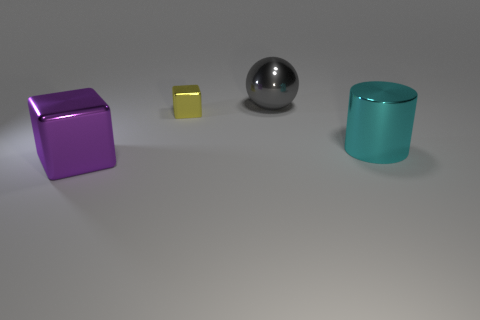Add 4 big cyan metal cylinders. How many objects exist? 8 Subtract all cylinders. How many objects are left? 3 Subtract all small metallic cubes. Subtract all small yellow objects. How many objects are left? 2 Add 4 large cyan shiny things. How many large cyan shiny things are left? 5 Add 1 big shiny cubes. How many big shiny cubes exist? 2 Subtract 0 green balls. How many objects are left? 4 